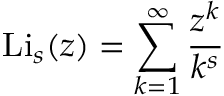Convert formula to latex. <formula><loc_0><loc_0><loc_500><loc_500>L i _ { s } ( z ) = \sum _ { k = 1 } ^ { \infty } { \frac { z ^ { k } } { k ^ { s } } }</formula> 